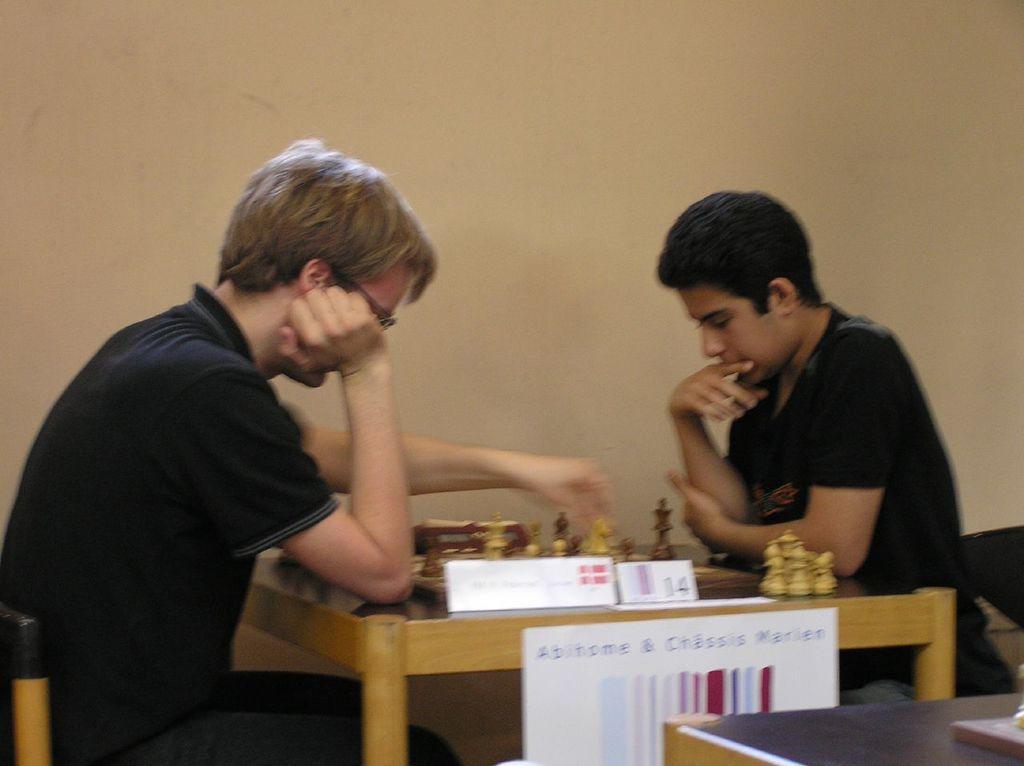Can you describe this image briefly? In the picture we can see a two boys sitting on the chairs in the opposite direction and a table between them and on it we can see a chess board and they are playing it and besides, we can see another table with a black surface on it and we can also see a wall. 